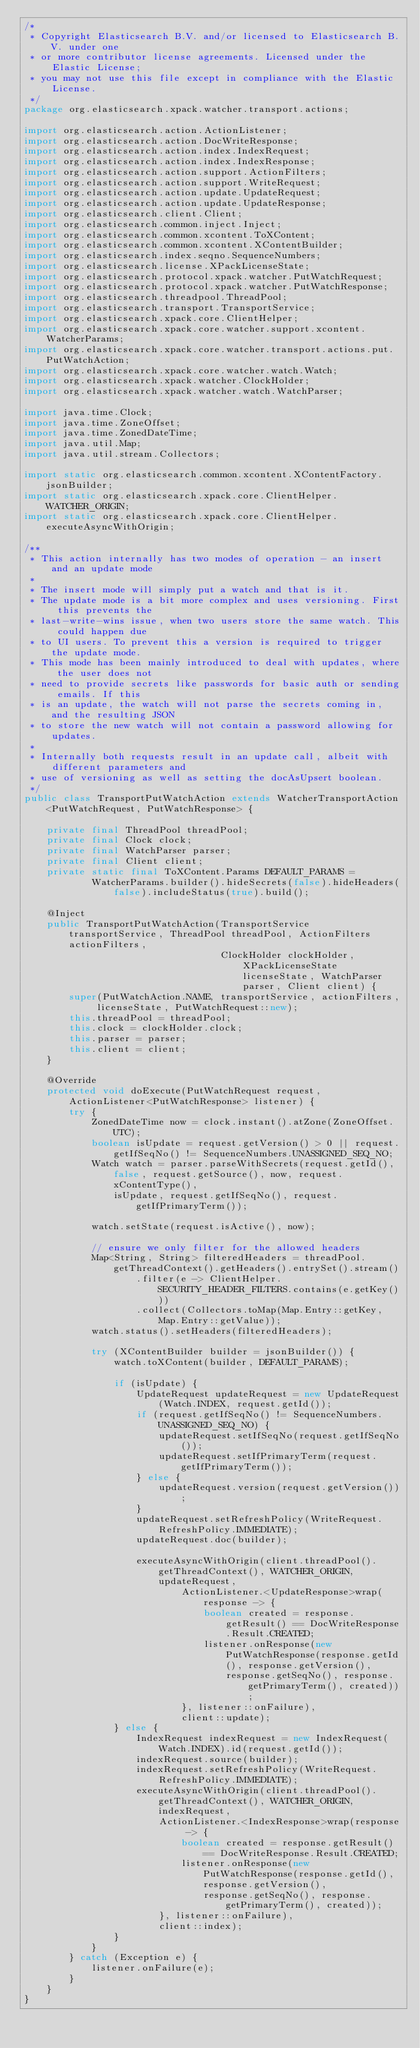<code> <loc_0><loc_0><loc_500><loc_500><_Java_>/*
 * Copyright Elasticsearch B.V. and/or licensed to Elasticsearch B.V. under one
 * or more contributor license agreements. Licensed under the Elastic License;
 * you may not use this file except in compliance with the Elastic License.
 */
package org.elasticsearch.xpack.watcher.transport.actions;

import org.elasticsearch.action.ActionListener;
import org.elasticsearch.action.DocWriteResponse;
import org.elasticsearch.action.index.IndexRequest;
import org.elasticsearch.action.index.IndexResponse;
import org.elasticsearch.action.support.ActionFilters;
import org.elasticsearch.action.support.WriteRequest;
import org.elasticsearch.action.update.UpdateRequest;
import org.elasticsearch.action.update.UpdateResponse;
import org.elasticsearch.client.Client;
import org.elasticsearch.common.inject.Inject;
import org.elasticsearch.common.xcontent.ToXContent;
import org.elasticsearch.common.xcontent.XContentBuilder;
import org.elasticsearch.index.seqno.SequenceNumbers;
import org.elasticsearch.license.XPackLicenseState;
import org.elasticsearch.protocol.xpack.watcher.PutWatchRequest;
import org.elasticsearch.protocol.xpack.watcher.PutWatchResponse;
import org.elasticsearch.threadpool.ThreadPool;
import org.elasticsearch.transport.TransportService;
import org.elasticsearch.xpack.core.ClientHelper;
import org.elasticsearch.xpack.core.watcher.support.xcontent.WatcherParams;
import org.elasticsearch.xpack.core.watcher.transport.actions.put.PutWatchAction;
import org.elasticsearch.xpack.core.watcher.watch.Watch;
import org.elasticsearch.xpack.watcher.ClockHolder;
import org.elasticsearch.xpack.watcher.watch.WatchParser;

import java.time.Clock;
import java.time.ZoneOffset;
import java.time.ZonedDateTime;
import java.util.Map;
import java.util.stream.Collectors;

import static org.elasticsearch.common.xcontent.XContentFactory.jsonBuilder;
import static org.elasticsearch.xpack.core.ClientHelper.WATCHER_ORIGIN;
import static org.elasticsearch.xpack.core.ClientHelper.executeAsyncWithOrigin;

/**
 * This action internally has two modes of operation - an insert and an update mode
 *
 * The insert mode will simply put a watch and that is it.
 * The update mode is a bit more complex and uses versioning. First this prevents the
 * last-write-wins issue, when two users store the same watch. This could happen due
 * to UI users. To prevent this a version is required to trigger the update mode.
 * This mode has been mainly introduced to deal with updates, where the user does not
 * need to provide secrets like passwords for basic auth or sending emails. If this
 * is an update, the watch will not parse the secrets coming in, and the resulting JSON
 * to store the new watch will not contain a password allowing for updates.
 *
 * Internally both requests result in an update call, albeit with different parameters and
 * use of versioning as well as setting the docAsUpsert boolean.
 */
public class TransportPutWatchAction extends WatcherTransportAction<PutWatchRequest, PutWatchResponse> {

    private final ThreadPool threadPool;
    private final Clock clock;
    private final WatchParser parser;
    private final Client client;
    private static final ToXContent.Params DEFAULT_PARAMS =
            WatcherParams.builder().hideSecrets(false).hideHeaders(false).includeStatus(true).build();

    @Inject
    public TransportPutWatchAction(TransportService transportService, ThreadPool threadPool, ActionFilters actionFilters,
                                   ClockHolder clockHolder, XPackLicenseState licenseState, WatchParser parser, Client client) {
        super(PutWatchAction.NAME, transportService, actionFilters, licenseState, PutWatchRequest::new);
        this.threadPool = threadPool;
        this.clock = clockHolder.clock;
        this.parser = parser;
        this.client = client;
    }

    @Override
    protected void doExecute(PutWatchRequest request, ActionListener<PutWatchResponse> listener) {
        try {
            ZonedDateTime now = clock.instant().atZone(ZoneOffset.UTC);
            boolean isUpdate = request.getVersion() > 0 || request.getIfSeqNo() != SequenceNumbers.UNASSIGNED_SEQ_NO;
            Watch watch = parser.parseWithSecrets(request.getId(), false, request.getSource(), now, request.xContentType(),
                isUpdate, request.getIfSeqNo(), request.getIfPrimaryTerm());

            watch.setState(request.isActive(), now);

            // ensure we only filter for the allowed headers
            Map<String, String> filteredHeaders = threadPool.getThreadContext().getHeaders().entrySet().stream()
                    .filter(e -> ClientHelper.SECURITY_HEADER_FILTERS.contains(e.getKey()))
                    .collect(Collectors.toMap(Map.Entry::getKey, Map.Entry::getValue));
            watch.status().setHeaders(filteredHeaders);

            try (XContentBuilder builder = jsonBuilder()) {
                watch.toXContent(builder, DEFAULT_PARAMS);

                if (isUpdate) {
                    UpdateRequest updateRequest = new UpdateRequest(Watch.INDEX, request.getId());
                    if (request.getIfSeqNo() != SequenceNumbers.UNASSIGNED_SEQ_NO) {
                        updateRequest.setIfSeqNo(request.getIfSeqNo());
                        updateRequest.setIfPrimaryTerm(request.getIfPrimaryTerm());
                    } else {
                        updateRequest.version(request.getVersion());
                    }
                    updateRequest.setRefreshPolicy(WriteRequest.RefreshPolicy.IMMEDIATE);
                    updateRequest.doc(builder);

                    executeAsyncWithOrigin(client.threadPool().getThreadContext(), WATCHER_ORIGIN, updateRequest,
                            ActionListener.<UpdateResponse>wrap(response -> {
                                boolean created = response.getResult() == DocWriteResponse.Result.CREATED;
                                listener.onResponse(new PutWatchResponse(response.getId(), response.getVersion(),
                                    response.getSeqNo(), response.getPrimaryTerm(), created));
                            }, listener::onFailure),
                            client::update);
                } else {
                    IndexRequest indexRequest = new IndexRequest(Watch.INDEX).id(request.getId());
                    indexRequest.source(builder);
                    indexRequest.setRefreshPolicy(WriteRequest.RefreshPolicy.IMMEDIATE);
                    executeAsyncWithOrigin(client.threadPool().getThreadContext(), WATCHER_ORIGIN, indexRequest,
                        ActionListener.<IndexResponse>wrap(response -> {
                            boolean created = response.getResult() == DocWriteResponse.Result.CREATED;
                            listener.onResponse(new PutWatchResponse(response.getId(), response.getVersion(),
                                response.getSeqNo(), response.getPrimaryTerm(), created));
                        }, listener::onFailure),
                        client::index);
                }
            }
        } catch (Exception e) {
            listener.onFailure(e);
        }
    }
}
</code> 